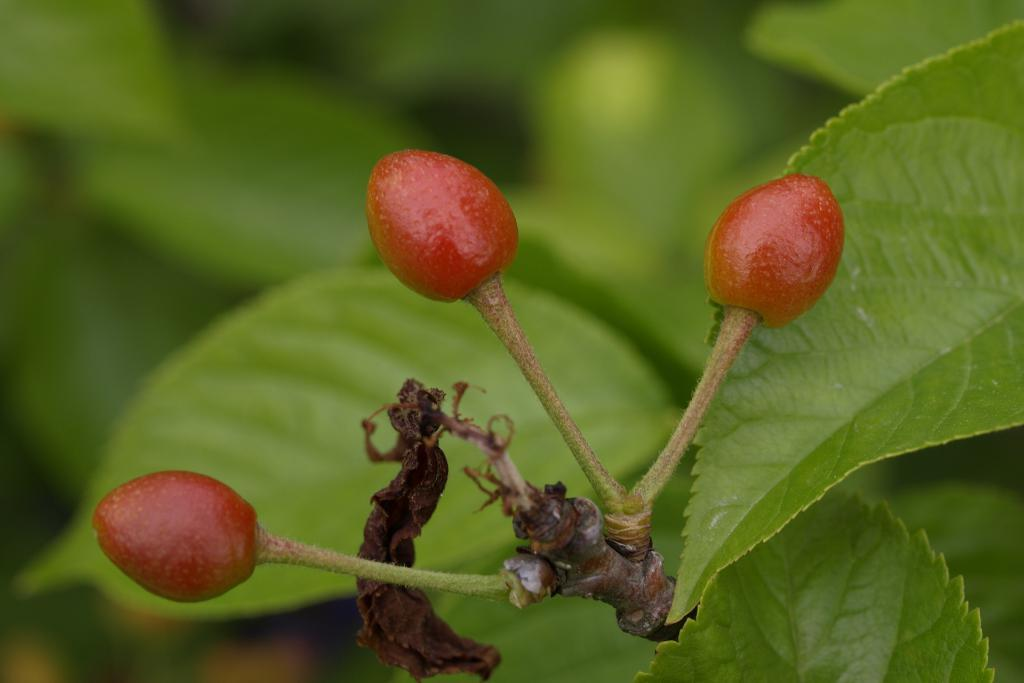What color can be seen on some objects in the image? There are red color things in the image. What type of vegetation is present in the image? There are green leaves in the image. How would you describe the background of the image? The background of the image is blurred. How many woolen hats can be seen on the cows during their trip in the image? There are no cows, woolen hats, or trips depicted in the image. 